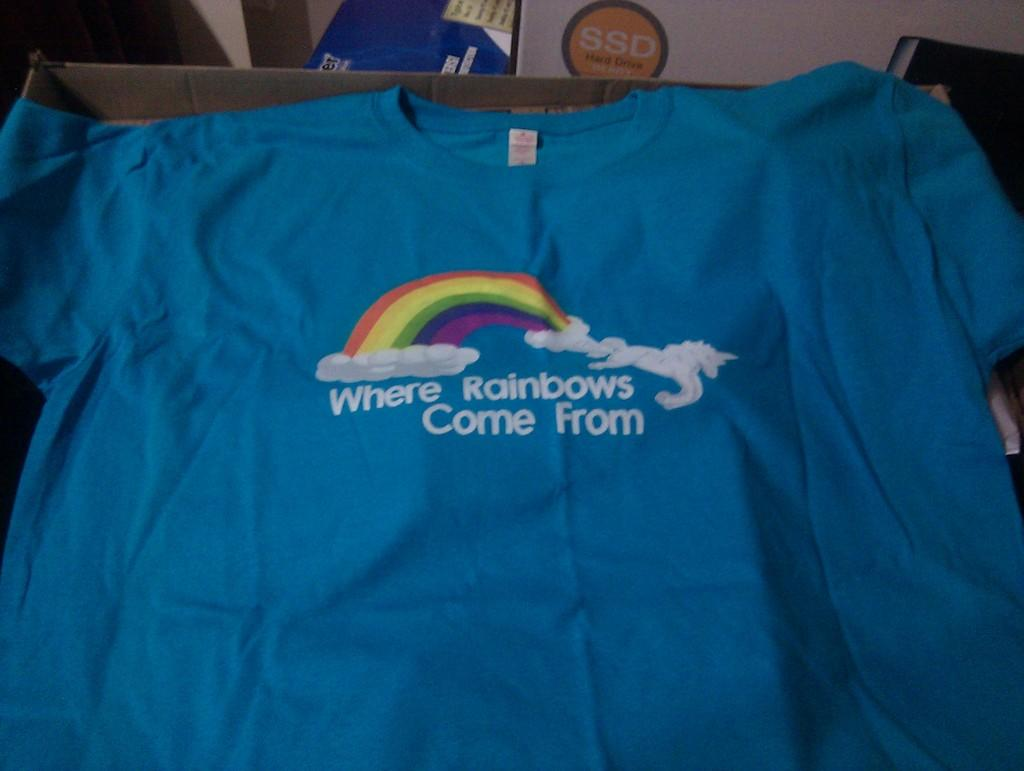<image>
Offer a succinct explanation of the picture presented. a shirt in a box that say Where Rainbows Come From 